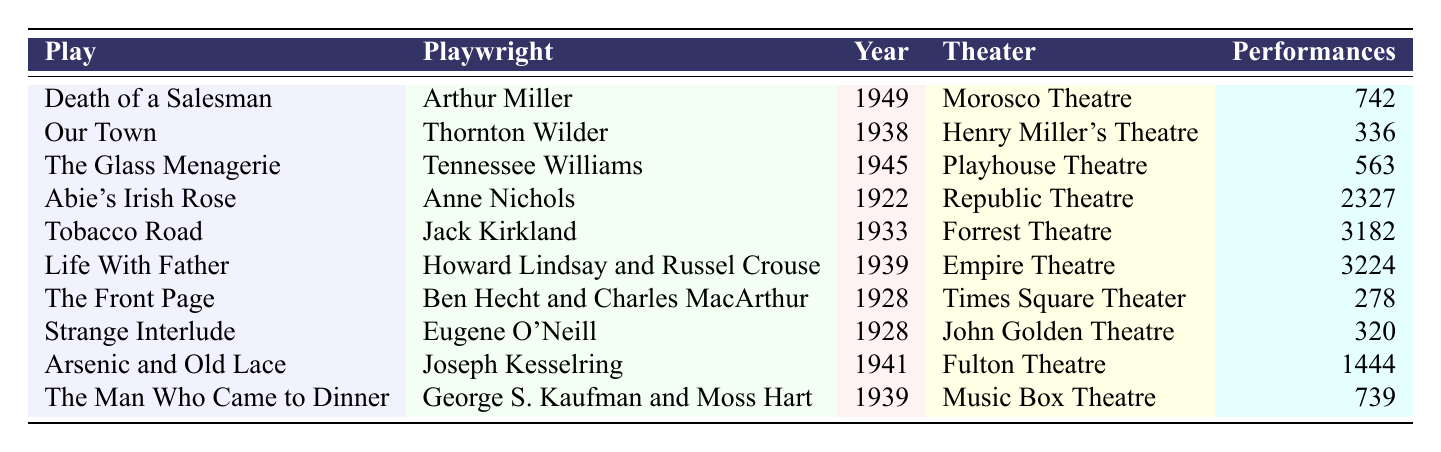What is the total number of performances for "Life With Father"? The table lists "Life With Father" with 3,224 performances in the column for Performances.
Answer: 3224 Who is the playwright of "The Glass Menagerie"? The table shows "The Glass Menagerie" written by Tennessee Williams in the column for Playwright.
Answer: Tennessee Williams Which play had the highest number of performances? By comparing the performances listed, "Tobacco Road" has 3,182 performances, which is higher than any other play in the table.
Answer: Tobacco Road What year was "Arsenic and Old Lace" performed? The table indicates that "Arsenic and Old Lace" was performed in the year 1941, found in the Year column.
Answer: 1941 How many performances did "Our Town" have? The table states that "Our Town" had 336 performances, as shown in the Performances column.
Answer: 336 What is the difference in performances between "Death of a Salesman" and "The Front Page"? "Death of a Salesman" had 742 performances while "The Front Page" had 278 performances. The difference is 742 - 278 = 464.
Answer: 464 Which plays were performed in the same theater as "The Man Who Came to Dinner"? The table lists "The Man Who Came to Dinner" at the Music Box Theatre, and no other play is listed under the same theater; thus, there are no other performances in that theater in this data.
Answer: No other plays Is "Abie's Irish Rose" the longest-running play among those listed? Yes, comparing all values in the Performances column, "Abie's Irish Rose" has 2,327 performances, which is greater than any other play.
Answer: Yes What is the average number of performances for plays from the year 1928? The year 1928 has two plays: "The Front Page" (278 performances) and "Strange Interlude" (320 performances). The sum is 278 + 320 = 598, and the average is 598 / 2 = 299.
Answer: 299 Identify the theater where the most performed play, "Tobacco Road," was staged. The table indicates that "Tobacco Road" was staged at the Forrest Theatre.
Answer: Forrest Theatre 